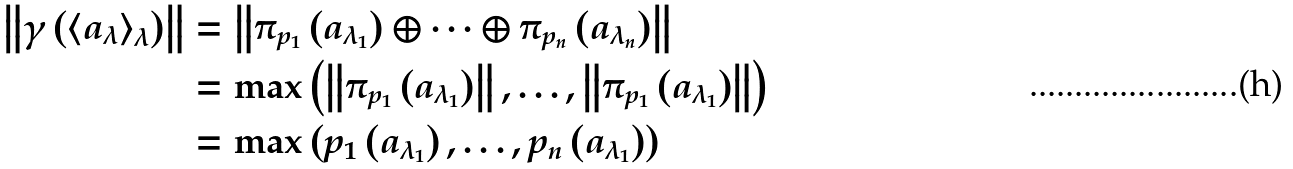<formula> <loc_0><loc_0><loc_500><loc_500>\left \| \gamma \left ( \left \langle a _ { \lambda } \right \rangle _ { \lambda } \right ) \right \| & = \left \| \pi _ { p _ { 1 } } \left ( a _ { \lambda _ { 1 } } \right ) \oplus \cdots \oplus \pi _ { p _ { n } } \left ( a _ { \lambda _ { n } } \right ) \right \| \\ & = \max \left ( \left \| \pi _ { p _ { 1 } } \left ( a _ { \lambda _ { 1 } } \right ) \right \| , \dots , \left \| \pi _ { p _ { 1 } } \left ( a _ { \lambda _ { 1 } } \right ) \right \| \right ) \\ & = \max \left ( p _ { 1 } \left ( a _ { \lambda _ { 1 } } \right ) , \dots , p _ { n } \left ( a _ { \lambda _ { 1 } } \right ) \right )</formula> 